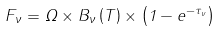Convert formula to latex. <formula><loc_0><loc_0><loc_500><loc_500>F _ { \nu } = \Omega \times B _ { \nu } \left ( T \right ) \times \left ( 1 - e ^ { - \tau _ { \nu } } \right )</formula> 